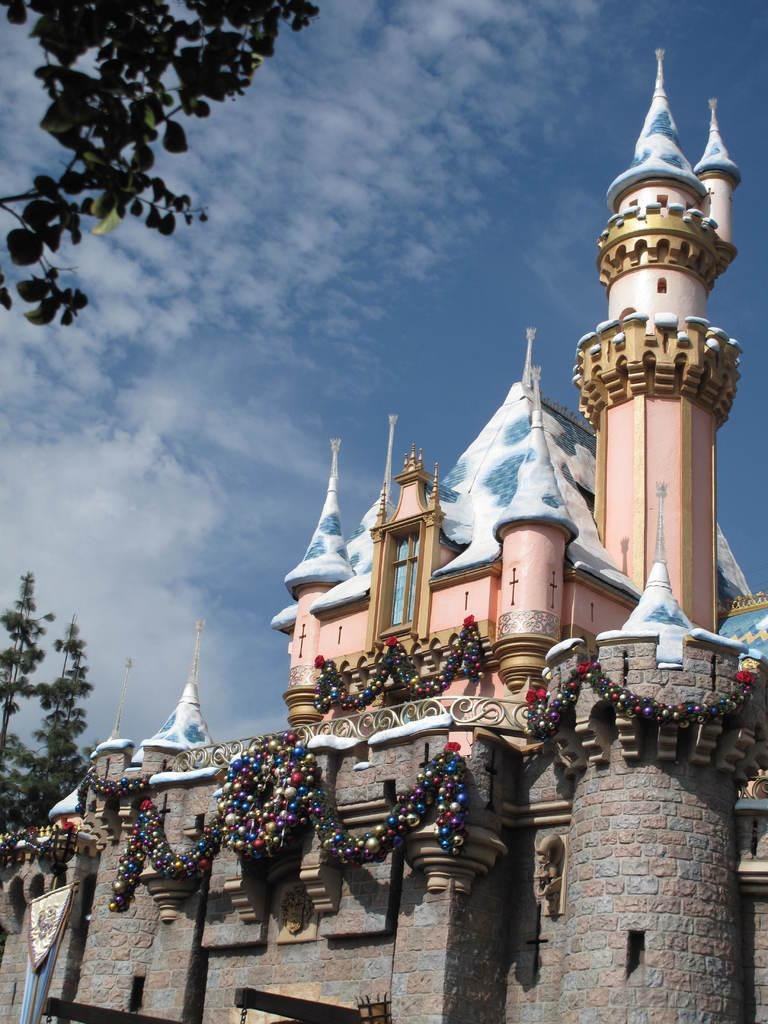What type of structure is in the image? There is a building in the image. What else can be seen in the image besides the building? Decorative items and leaves are visible in the image. What is visible in the background of the image? The sky is visible in the background of the image. What can be observed in the sky? Clouds are present in the sky. Where are the leaves located in the image? Leaves are present in the top left side of the image. How much money is being exchanged in the image? There is no indication of money or any transaction in the image. What type of plane can be seen flying in the image? There is no plane visible in the image. 